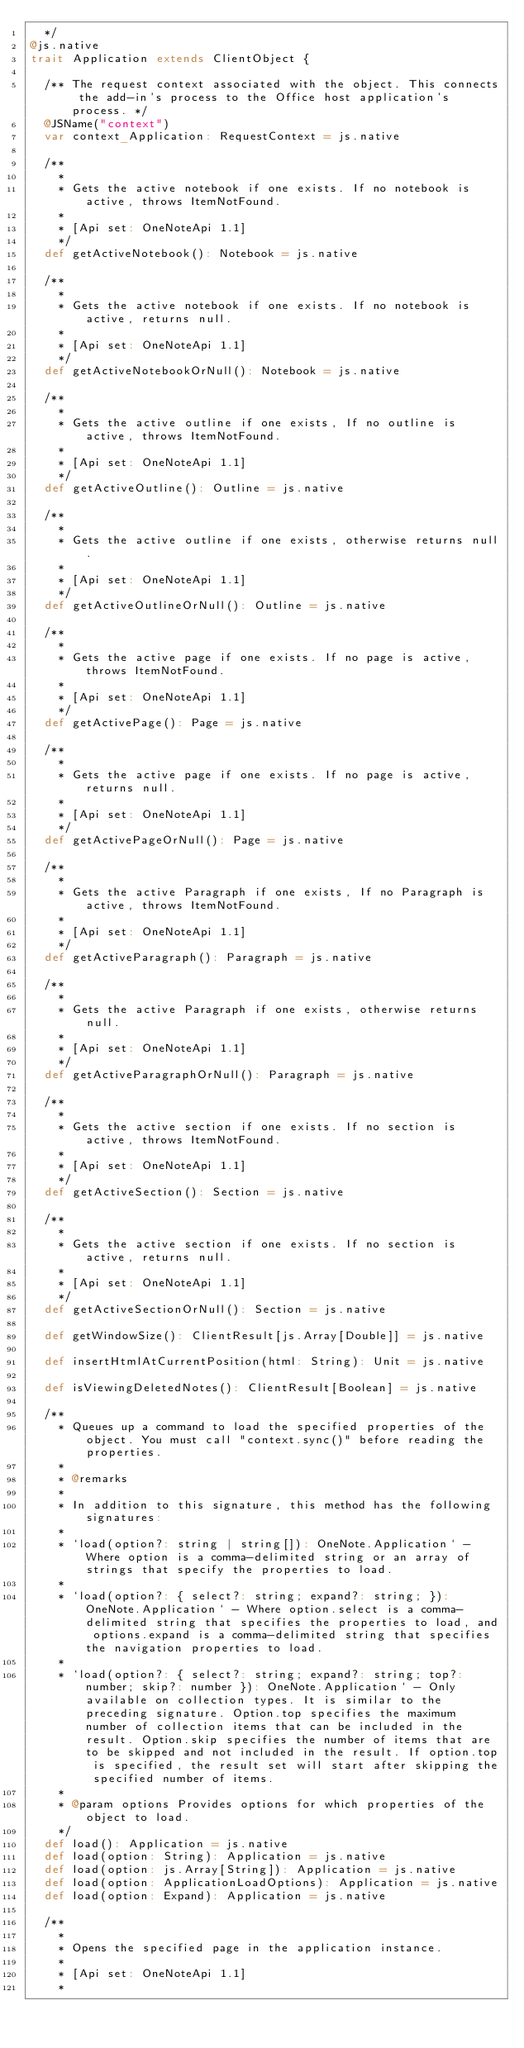<code> <loc_0><loc_0><loc_500><loc_500><_Scala_>  */
@js.native
trait Application extends ClientObject {
  
  /** The request context associated with the object. This connects the add-in's process to the Office host application's process. */
  @JSName("context")
  var context_Application: RequestContext = js.native
  
  /**
    *
    * Gets the active notebook if one exists. If no notebook is active, throws ItemNotFound.
    *
    * [Api set: OneNoteApi 1.1]
    */
  def getActiveNotebook(): Notebook = js.native
  
  /**
    *
    * Gets the active notebook if one exists. If no notebook is active, returns null.
    *
    * [Api set: OneNoteApi 1.1]
    */
  def getActiveNotebookOrNull(): Notebook = js.native
  
  /**
    *
    * Gets the active outline if one exists, If no outline is active, throws ItemNotFound.
    *
    * [Api set: OneNoteApi 1.1]
    */
  def getActiveOutline(): Outline = js.native
  
  /**
    *
    * Gets the active outline if one exists, otherwise returns null.
    *
    * [Api set: OneNoteApi 1.1]
    */
  def getActiveOutlineOrNull(): Outline = js.native
  
  /**
    *
    * Gets the active page if one exists. If no page is active, throws ItemNotFound.
    *
    * [Api set: OneNoteApi 1.1]
    */
  def getActivePage(): Page = js.native
  
  /**
    *
    * Gets the active page if one exists. If no page is active, returns null.
    *
    * [Api set: OneNoteApi 1.1]
    */
  def getActivePageOrNull(): Page = js.native
  
  /**
    *
    * Gets the active Paragraph if one exists, If no Paragraph is active, throws ItemNotFound.
    *
    * [Api set: OneNoteApi 1.1]
    */
  def getActiveParagraph(): Paragraph = js.native
  
  /**
    *
    * Gets the active Paragraph if one exists, otherwise returns null.
    *
    * [Api set: OneNoteApi 1.1]
    */
  def getActiveParagraphOrNull(): Paragraph = js.native
  
  /**
    *
    * Gets the active section if one exists. If no section is active, throws ItemNotFound.
    *
    * [Api set: OneNoteApi 1.1]
    */
  def getActiveSection(): Section = js.native
  
  /**
    *
    * Gets the active section if one exists. If no section is active, returns null.
    *
    * [Api set: OneNoteApi 1.1]
    */
  def getActiveSectionOrNull(): Section = js.native
  
  def getWindowSize(): ClientResult[js.Array[Double]] = js.native
  
  def insertHtmlAtCurrentPosition(html: String): Unit = js.native
  
  def isViewingDeletedNotes(): ClientResult[Boolean] = js.native
  
  /**
    * Queues up a command to load the specified properties of the object. You must call "context.sync()" before reading the properties.
    *
    * @remarks
    *
    * In addition to this signature, this method has the following signatures:
    *
    * `load(option?: string | string[]): OneNote.Application` - Where option is a comma-delimited string or an array of strings that specify the properties to load.
    *
    * `load(option?: { select?: string; expand?: string; }): OneNote.Application` - Where option.select is a comma-delimited string that specifies the properties to load, and options.expand is a comma-delimited string that specifies the navigation properties to load.
    *
    * `load(option?: { select?: string; expand?: string; top?: number; skip?: number }): OneNote.Application` - Only available on collection types. It is similar to the preceding signature. Option.top specifies the maximum number of collection items that can be included in the result. Option.skip specifies the number of items that are to be skipped and not included in the result. If option.top is specified, the result set will start after skipping the specified number of items.
    *
    * @param options Provides options for which properties of the object to load.
    */
  def load(): Application = js.native
  def load(option: String): Application = js.native
  def load(option: js.Array[String]): Application = js.native
  def load(option: ApplicationLoadOptions): Application = js.native
  def load(option: Expand): Application = js.native
  
  /**
    *
    * Opens the specified page in the application instance.
    *
    * [Api set: OneNoteApi 1.1]
    *</code> 